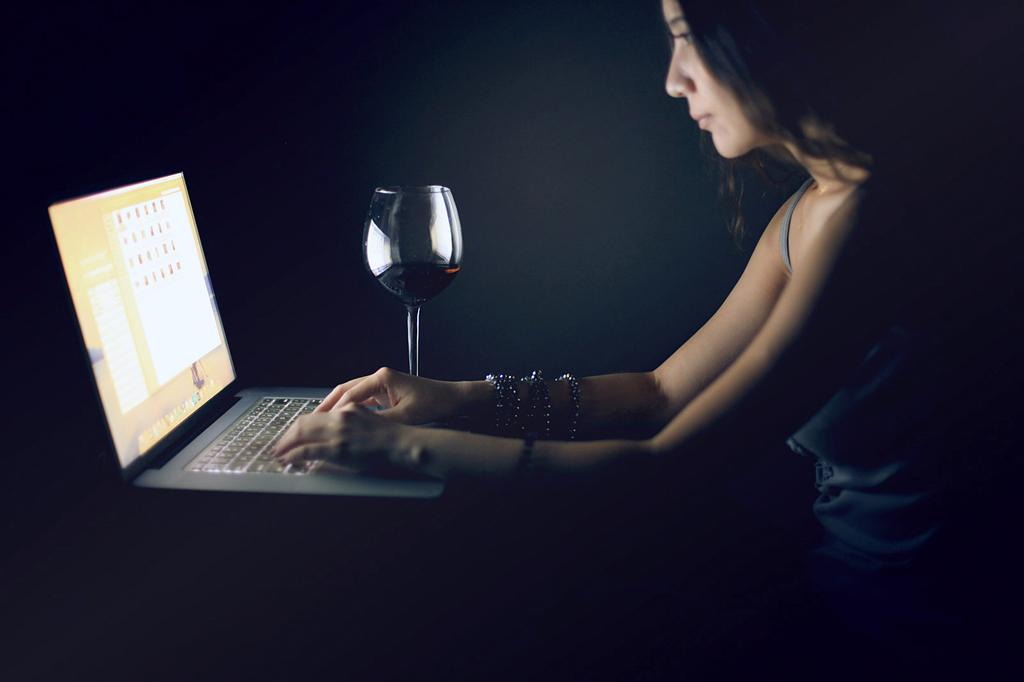Who is the main subject in the image? There is a woman in the image. What is the woman doing in the image? The woman is working with a laptop. Where is the laptop placed in the image? The laptop is on a surface. What else can be seen on the surface in the image? There is a glass filled with a drink on the surface. How would you describe the background of the image? The background of the image is dark in color. How many eggs are present in the image? There are no eggs visible in the image. What type of cover is protecting the laptop in the image? The laptop is not shown with a cover in the image. 